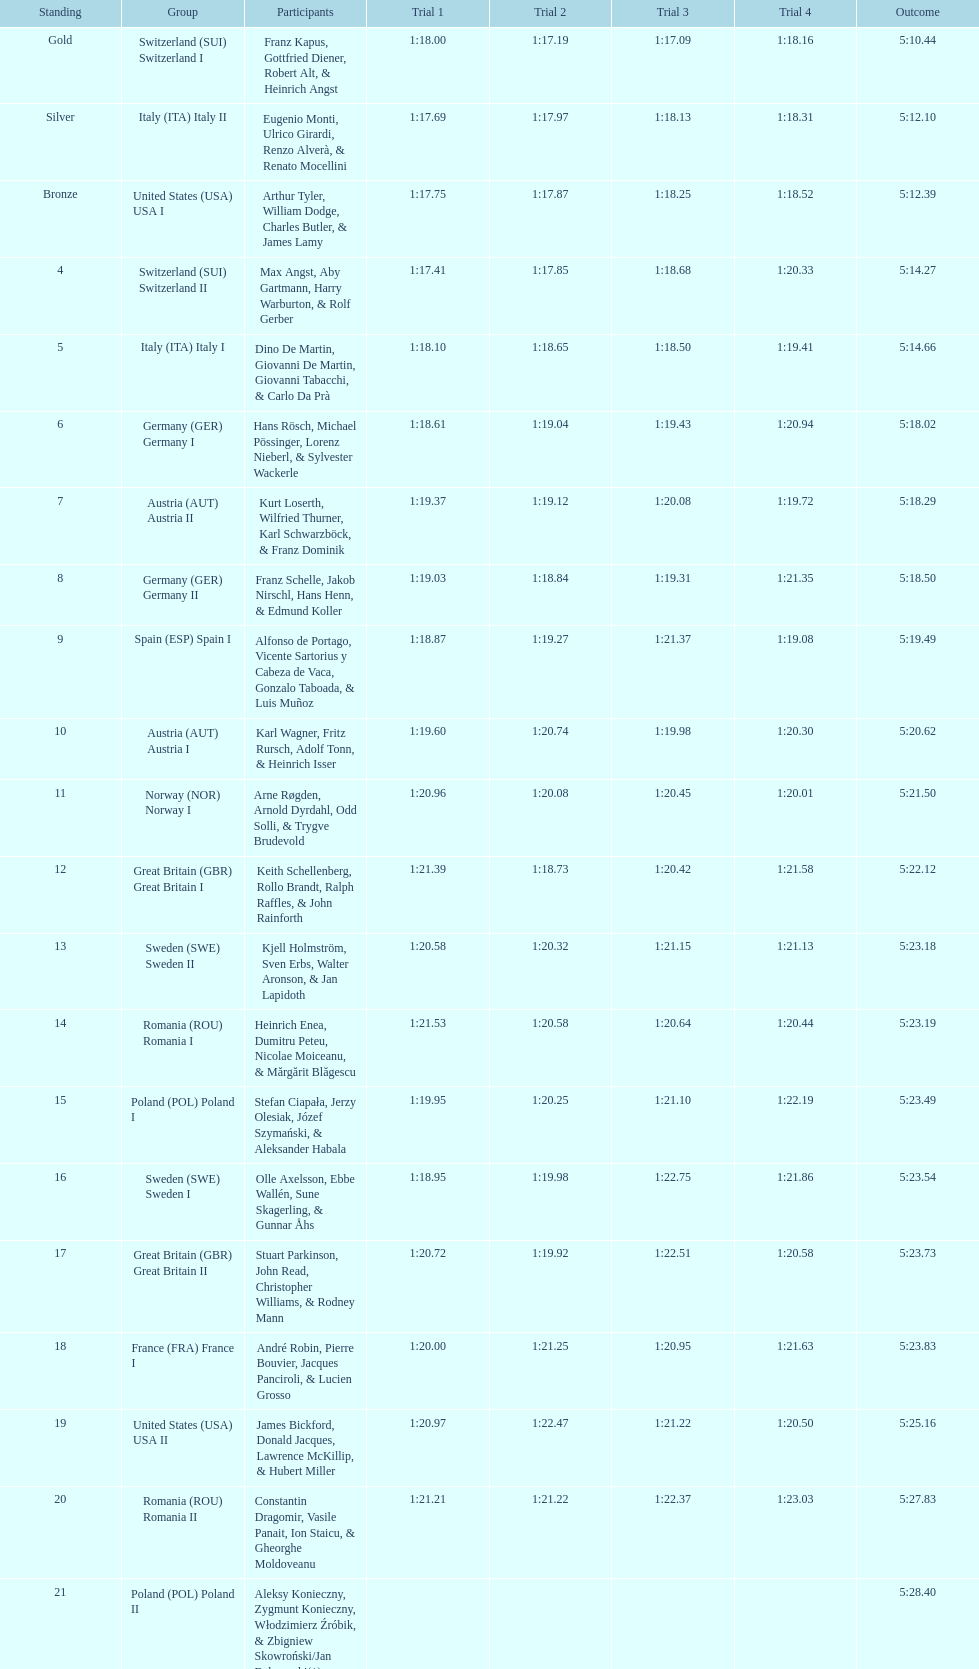Who placed the highest, italy or germany? Italy. 